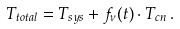Convert formula to latex. <formula><loc_0><loc_0><loc_500><loc_500>T _ { t o t a l } = T _ { s y s } + f _ { \nu } ( t ) \cdot T _ { c n } \, .</formula> 